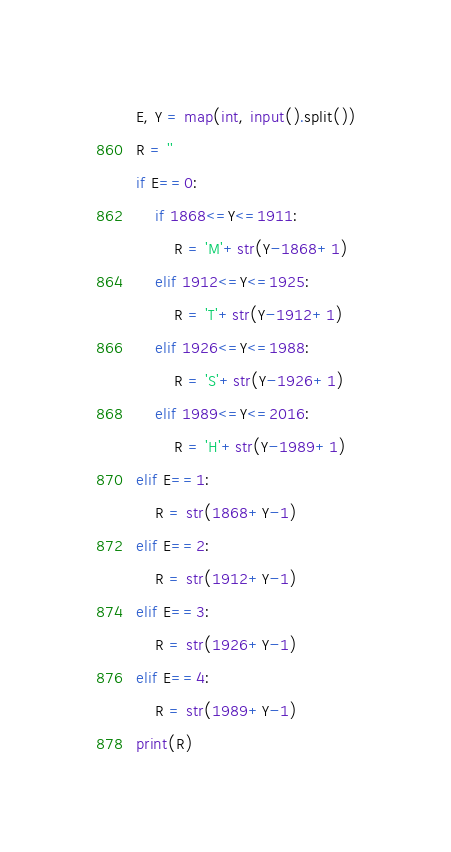<code> <loc_0><loc_0><loc_500><loc_500><_Python_>E, Y = map(int, input().split())
R = ''
if E==0:
	if 1868<=Y<=1911:
		R = 'M'+str(Y-1868+1)
	elif 1912<=Y<=1925:
		R = 'T'+str(Y-1912+1)
	elif 1926<=Y<=1988:
		R = 'S'+str(Y-1926+1)
	elif 1989<=Y<=2016:
		R = 'H'+str(Y-1989+1)
elif E==1:
	R = str(1868+Y-1)
elif E==2:
	R = str(1912+Y-1)
elif E==3:
	R = str(1926+Y-1)
elif E==4:
	R = str(1989+Y-1)
print(R)

</code> 